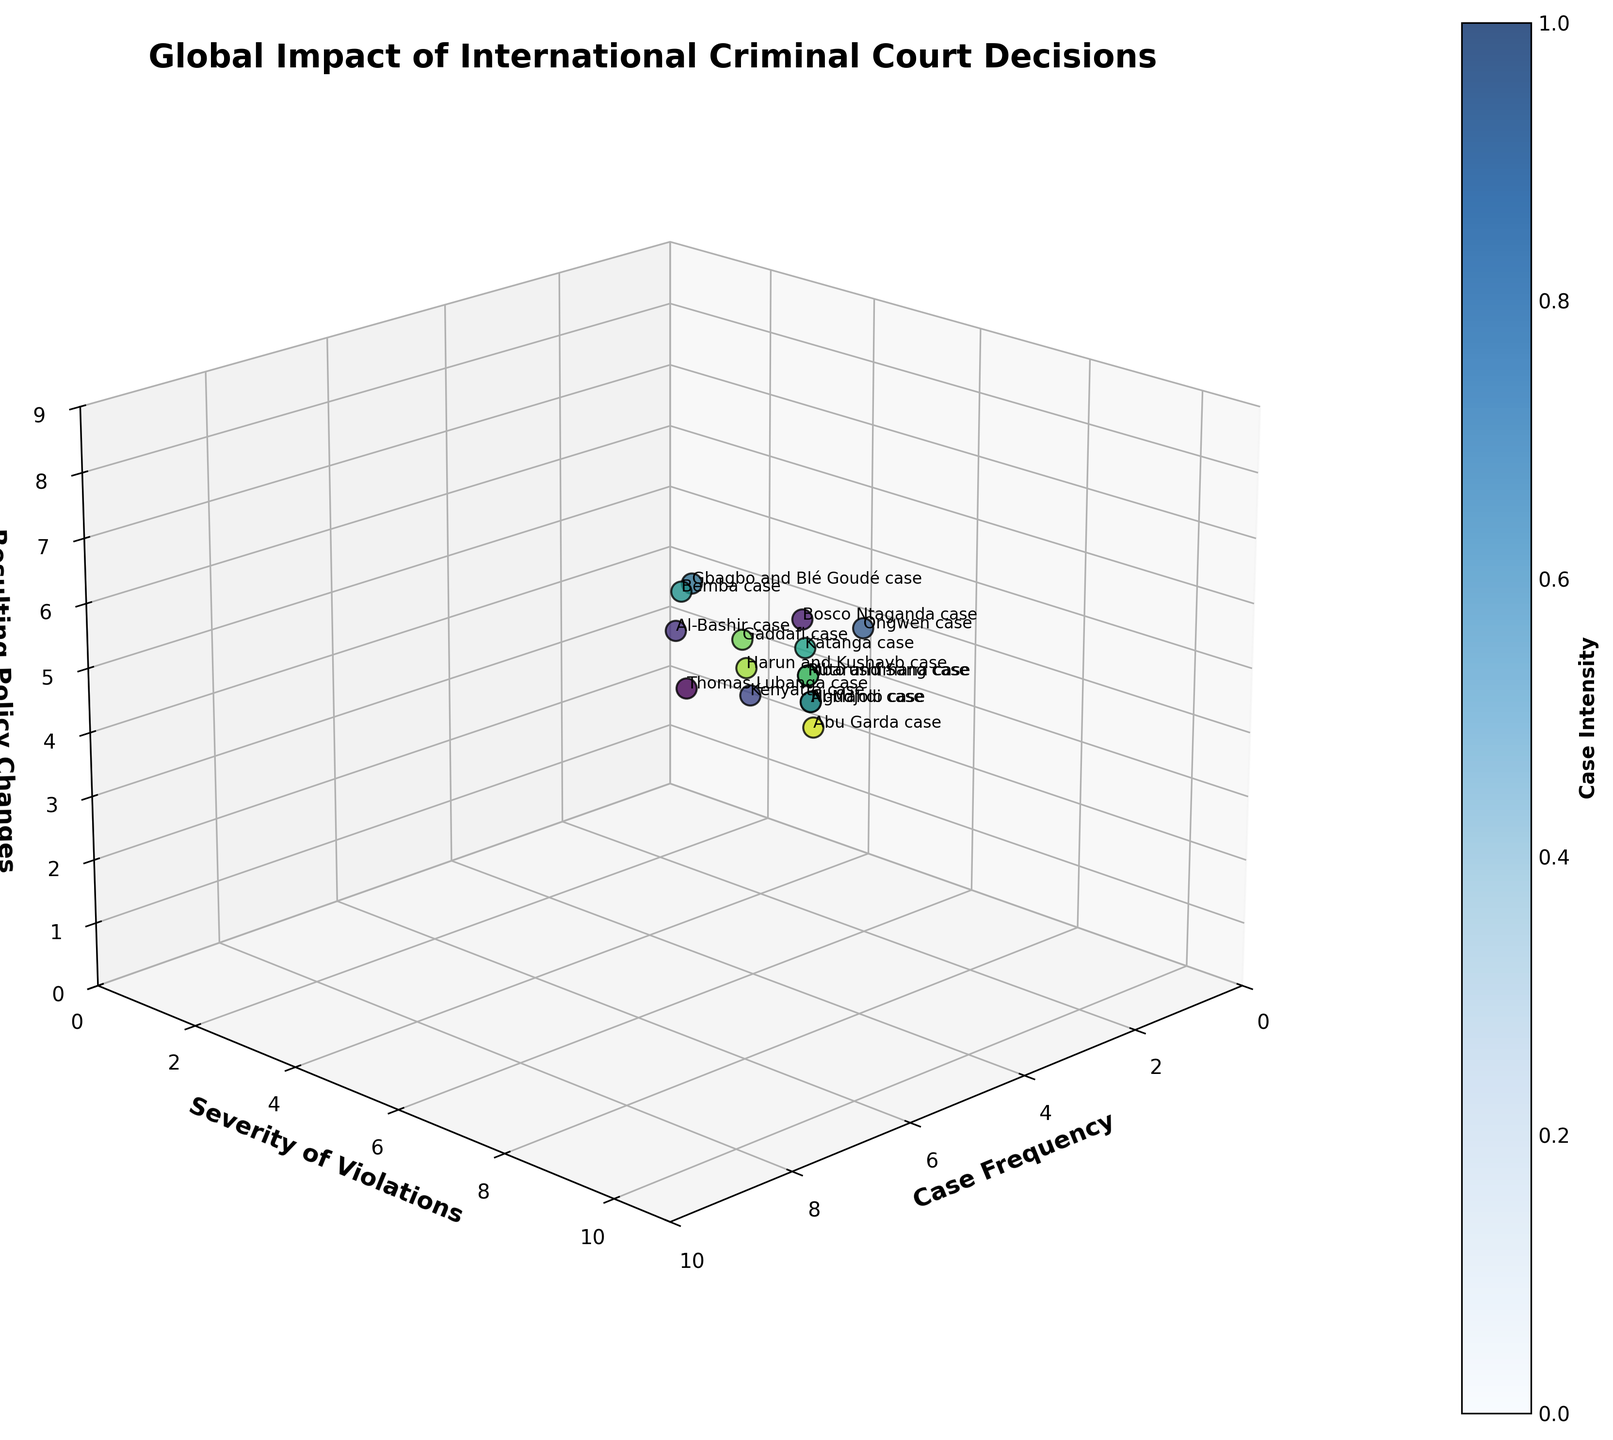Which case has the highest policy changes? The case with the highest value on the Policy Changes axis represents the case with the highest impact on policy changes.
Answer: Bemba case What is the title of the plot? The title is the main text at the top of the plot that usually describes the overall theme or subject.
Answer: Global Impact of International Criminal Court Decisions How many cases have a policy change value greater than 6? Count the number of data points (cases) with the z-axis (Policy Changes) value above 6.
Answer: 6 Which case appears to have the lowest frequency? The case with the smallest x-axis (Frequency) value.
Answer: Abu Garda case What's the average severity of violations for the cases that have a frequency of 6? Identify all cases with a Frequency of 6, sum their Severity values, and divide by the number of these cases.
Answer: 8 Which has a higher frequency: the Lumanga case or the Gaddafi case? Compare the x-axis (Frequency) values of the Lumanga case and the Gaddafi case.
Answer: Lumanga case How many cases are plotted in total? Count the total number of points (cases) represented in the scatter plot.
Answer: 15 What is the range of the severity of violations for all cases? Subtract the smallest y-axis (Severity) value from the largest y-axis value.
Answer: 10 - 5 = 5 In which dimension is the Kenyatta case positioned higher than the Katanga case? Compare where the Kenyatta case and the Katanga case are plotted along each axis.
Answer: y-axis (Severity) Which data point has an equal frequency and policy changes value? Find the case where the x-axis (Frequency) value matches the z-axis (Policy Changes) value.
Answer: Al-Mahdi case 